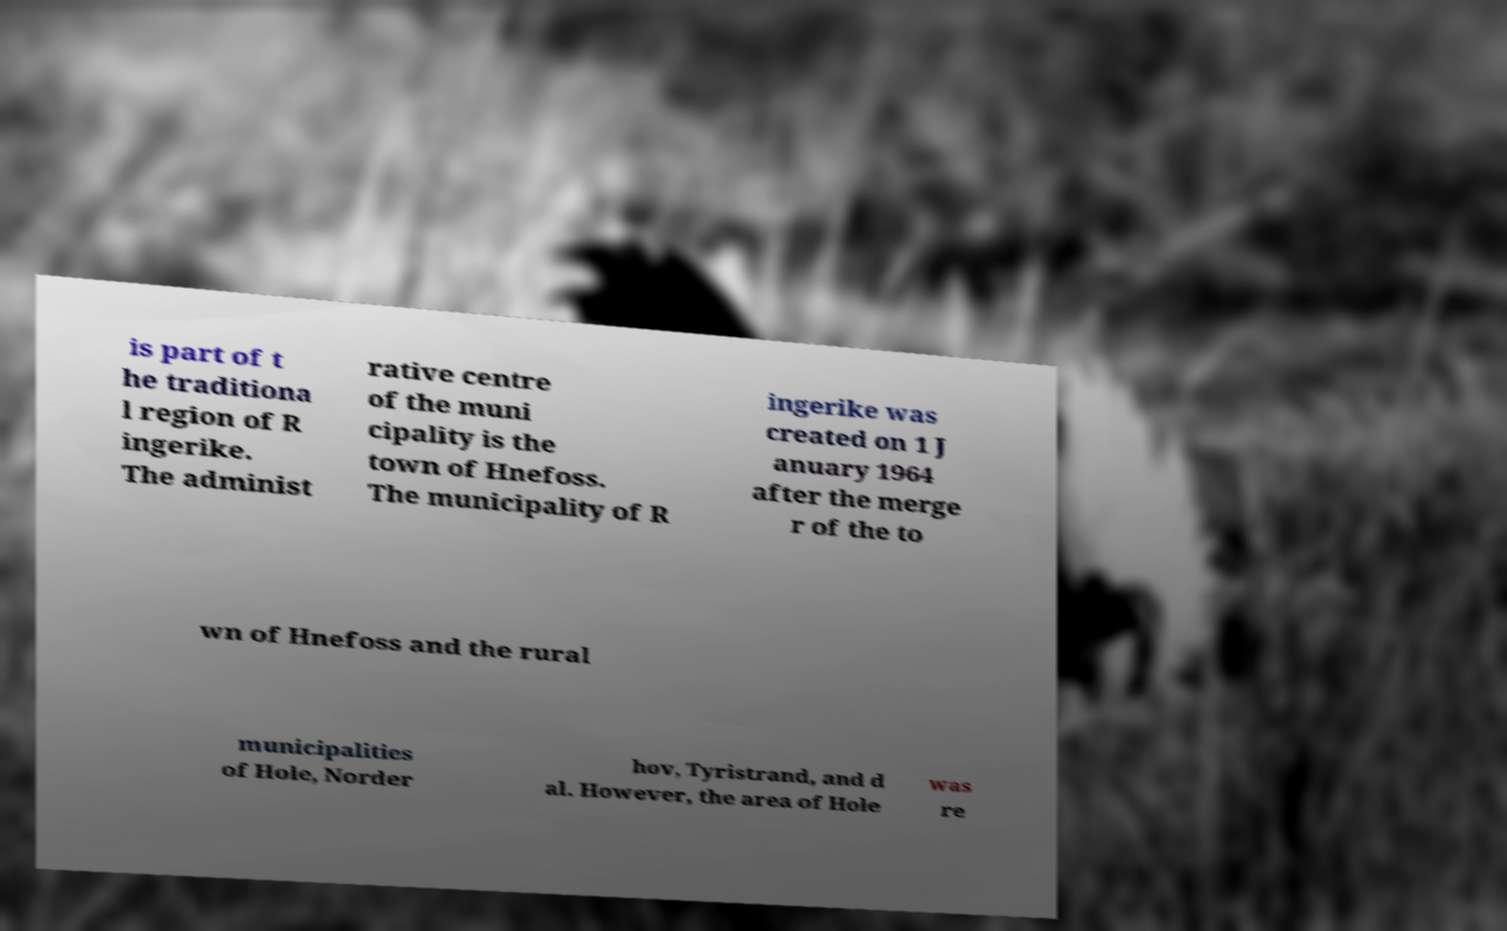Could you extract and type out the text from this image? is part of t he traditiona l region of R ingerike. The administ rative centre of the muni cipality is the town of Hnefoss. The municipality of R ingerike was created on 1 J anuary 1964 after the merge r of the to wn of Hnefoss and the rural municipalities of Hole, Norder hov, Tyristrand, and d al. However, the area of Hole was re 